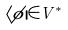Convert formula to latex. <formula><loc_0><loc_0><loc_500><loc_500>\langle \phi | \in V ^ { * }</formula> 